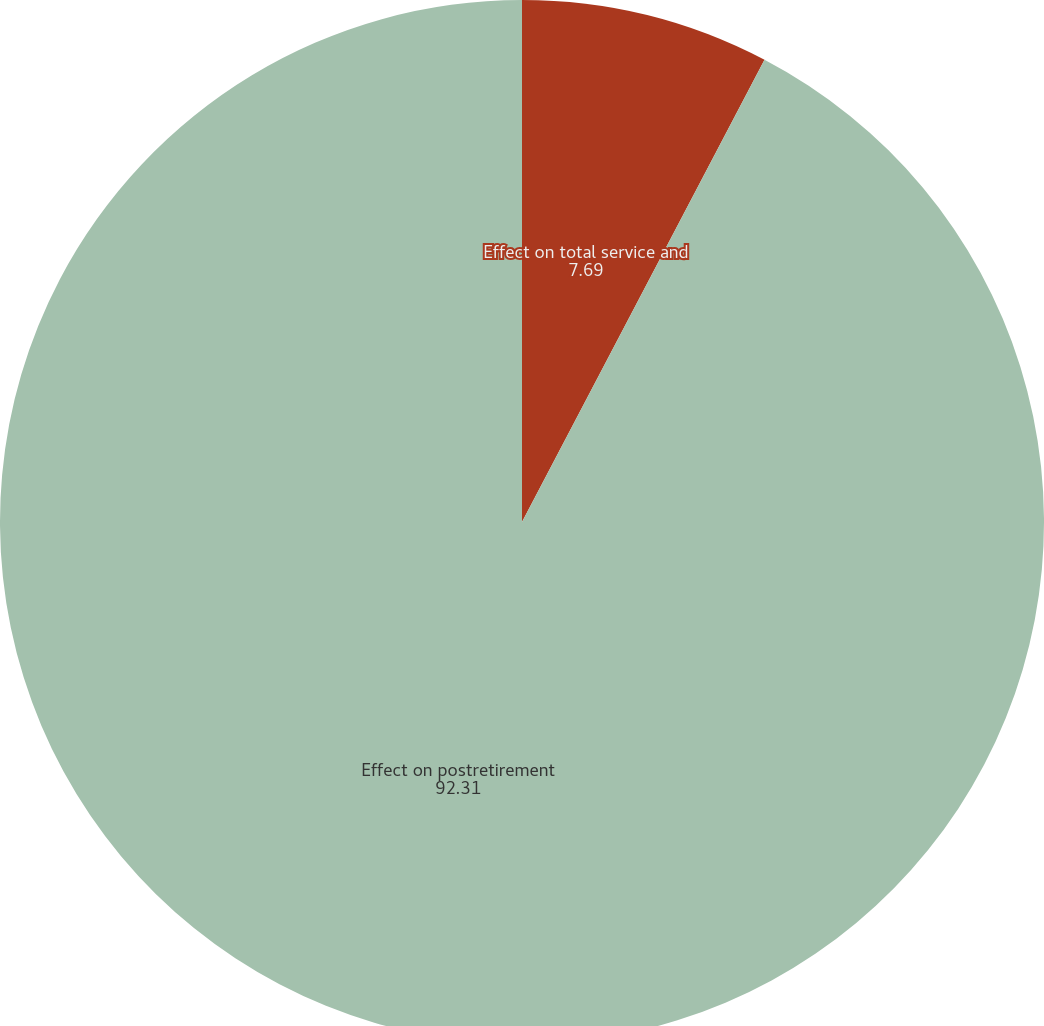Convert chart to OTSL. <chart><loc_0><loc_0><loc_500><loc_500><pie_chart><fcel>Effect on total service and<fcel>Effect on postretirement<nl><fcel>7.69%<fcel>92.31%<nl></chart> 